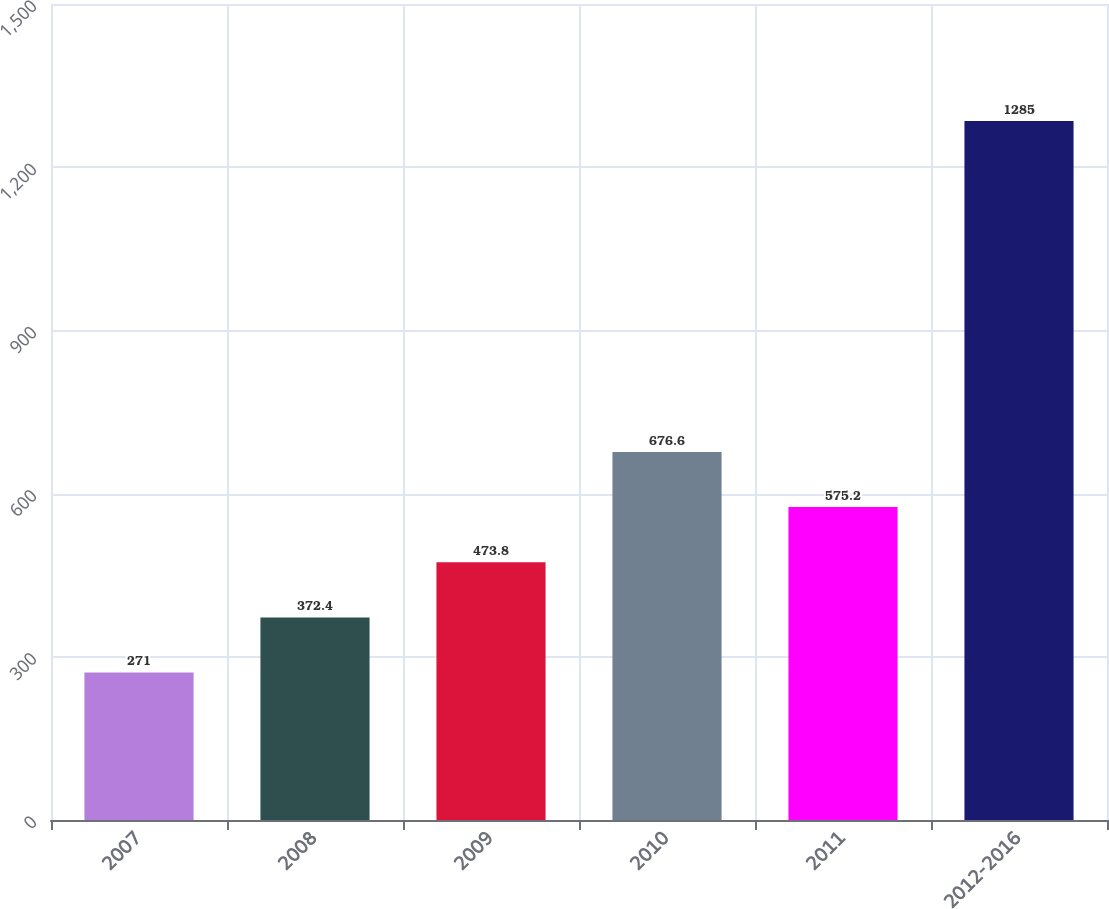Convert chart. <chart><loc_0><loc_0><loc_500><loc_500><bar_chart><fcel>2007<fcel>2008<fcel>2009<fcel>2010<fcel>2011<fcel>2012-2016<nl><fcel>271<fcel>372.4<fcel>473.8<fcel>676.6<fcel>575.2<fcel>1285<nl></chart> 